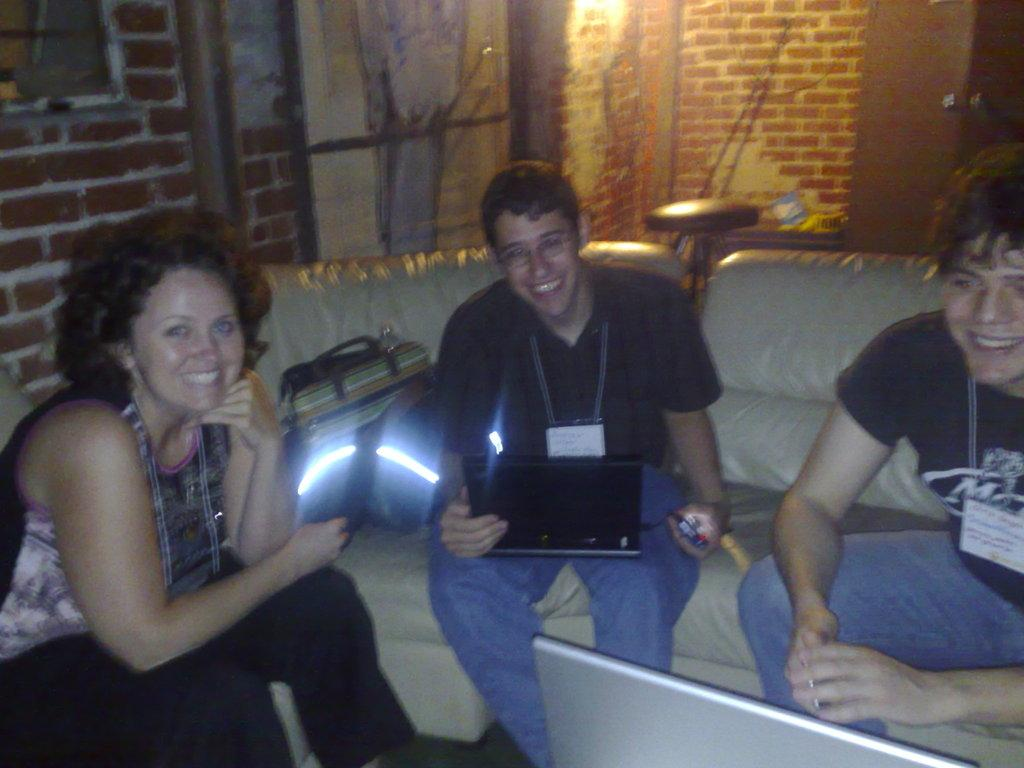How many people are sitting on the sofa in the image? There are three persons sitting on the sofa in the image. What else can be seen in the image besides the sofa? There is a bag in the image. What is visible in the background of the image? There is a wall and a chair in the background of the image. What type of twig is being used to pull the chair in the image? There is no twig or chair being pulled in the image; the chair is stationary in the background. 